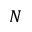<formula> <loc_0><loc_0><loc_500><loc_500>N</formula> 